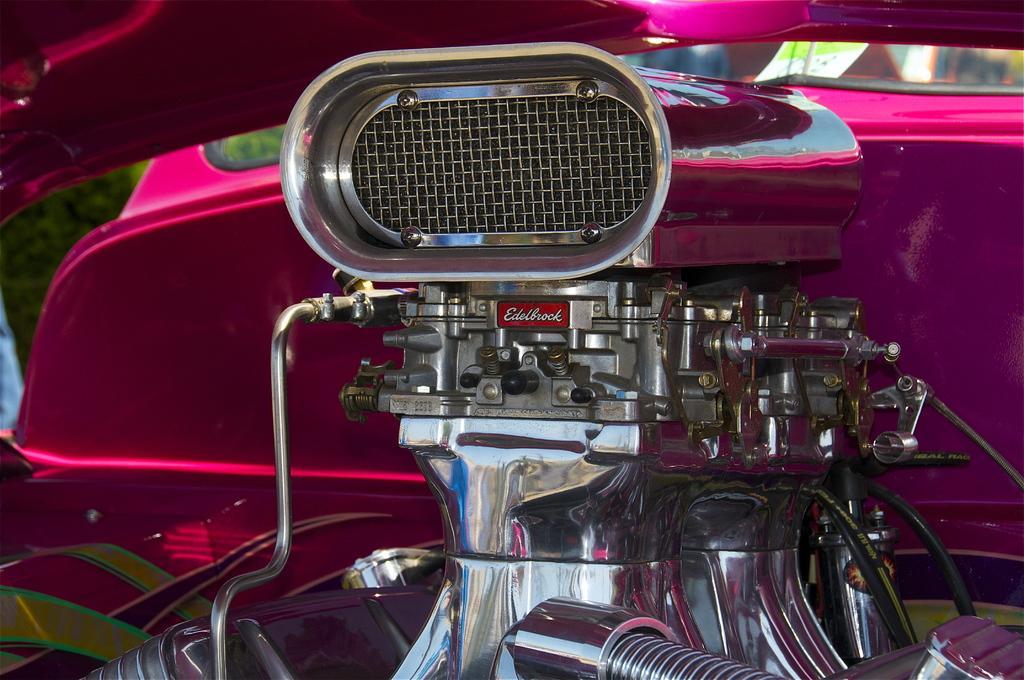Can you describe this image briefly? In this picture, it seems like parts of a bike. 